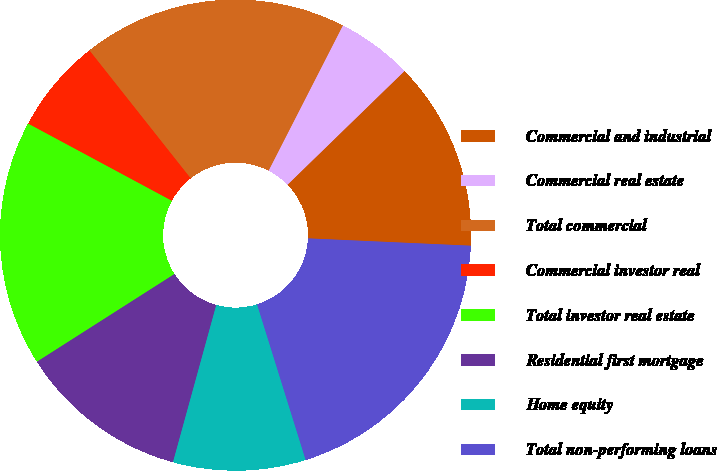<chart> <loc_0><loc_0><loc_500><loc_500><pie_chart><fcel>Commercial and industrial<fcel>Commercial real estate<fcel>Total commercial<fcel>Commercial investor real<fcel>Total investor real estate<fcel>Residential first mortgage<fcel>Home equity<fcel>Total non-performing loans<nl><fcel>12.99%<fcel>5.2%<fcel>18.18%<fcel>6.5%<fcel>16.88%<fcel>11.69%<fcel>9.09%<fcel>19.47%<nl></chart> 